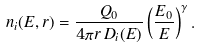<formula> <loc_0><loc_0><loc_500><loc_500>n _ { i } ( E , r ) = \frac { Q _ { 0 } } { 4 \pi r \, D _ { i } ( E ) } \left ( \frac { E _ { 0 } } { E } \right ) ^ { \gamma } .</formula> 